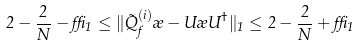<formula> <loc_0><loc_0><loc_500><loc_500>2 - \frac { 2 } { N } - \delta _ { 1 } \leq \| \tilde { Q } _ { f } ^ { \left ( i \right ) } \rho - U \rho U ^ { \dag } \| _ { 1 } \leq 2 - \frac { 2 } { N } + \delta _ { 1 }</formula> 